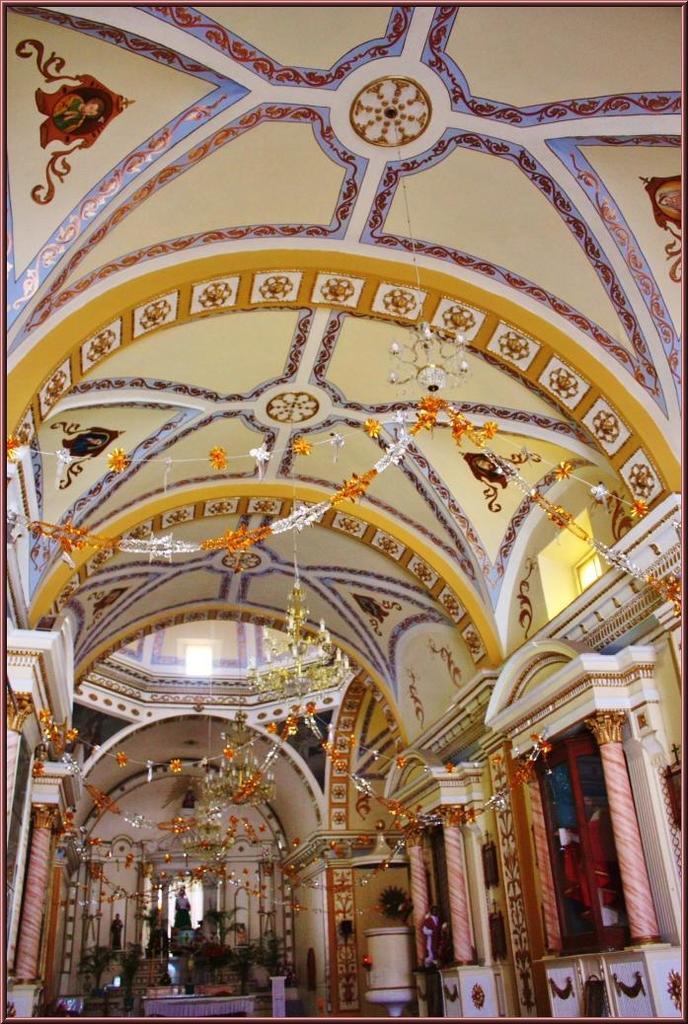Can you describe this image briefly? In this image I can see the inner part of the building. Inside the building I can see the podiums, decorative objects and statues. 